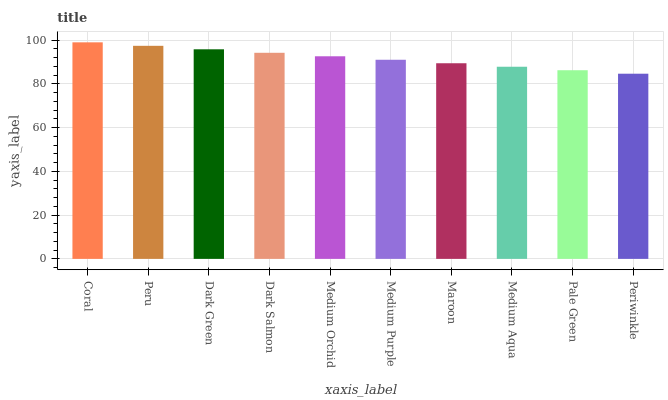Is Periwinkle the minimum?
Answer yes or no. Yes. Is Coral the maximum?
Answer yes or no. Yes. Is Peru the minimum?
Answer yes or no. No. Is Peru the maximum?
Answer yes or no. No. Is Coral greater than Peru?
Answer yes or no. Yes. Is Peru less than Coral?
Answer yes or no. Yes. Is Peru greater than Coral?
Answer yes or no. No. Is Coral less than Peru?
Answer yes or no. No. Is Medium Orchid the high median?
Answer yes or no. Yes. Is Medium Purple the low median?
Answer yes or no. Yes. Is Periwinkle the high median?
Answer yes or no. No. Is Peru the low median?
Answer yes or no. No. 